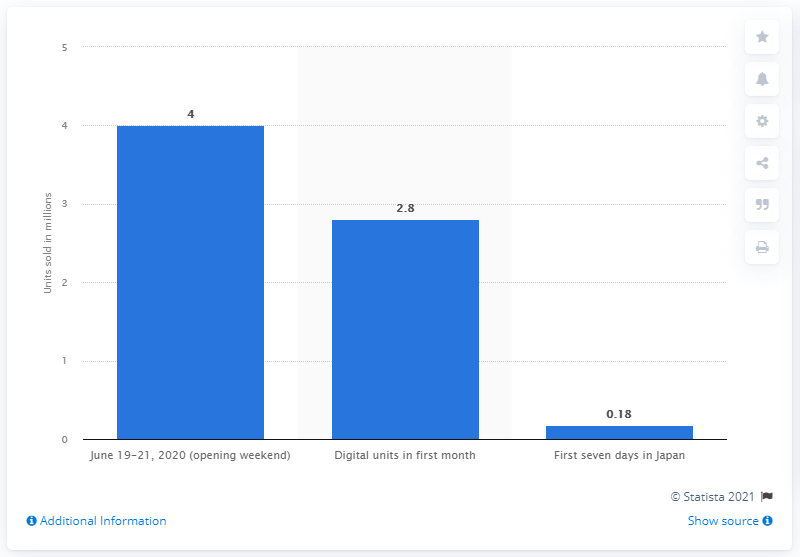Identify some key points in this picture. The Last of Us Part II sold 2.8 units in its first month. 